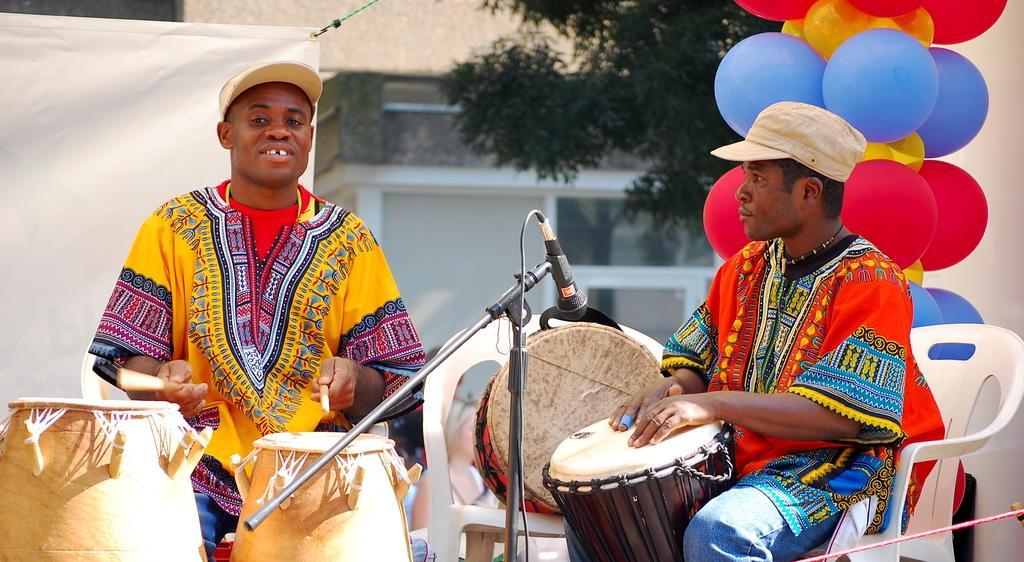In one or two sentences, can you explain what this image depicts? In this image I can see two people sitting and these people are playing musical instruments. In front of them there is a mic. At the of them there are balloons and the banner. In the background there is a tree and the building. 